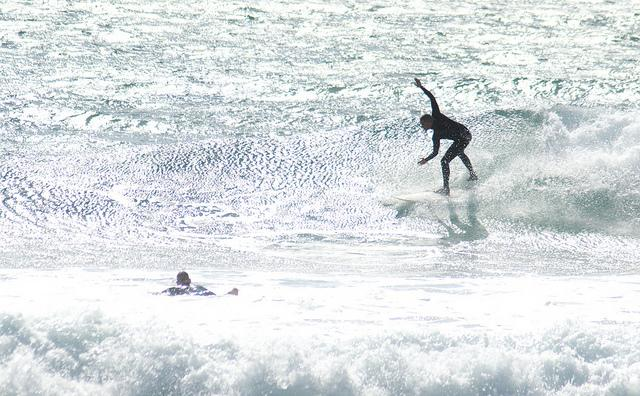Why is the man holding his arms out?

Choices:
A) to dance
B) to dive
C) to wave
D) to balance to balance 